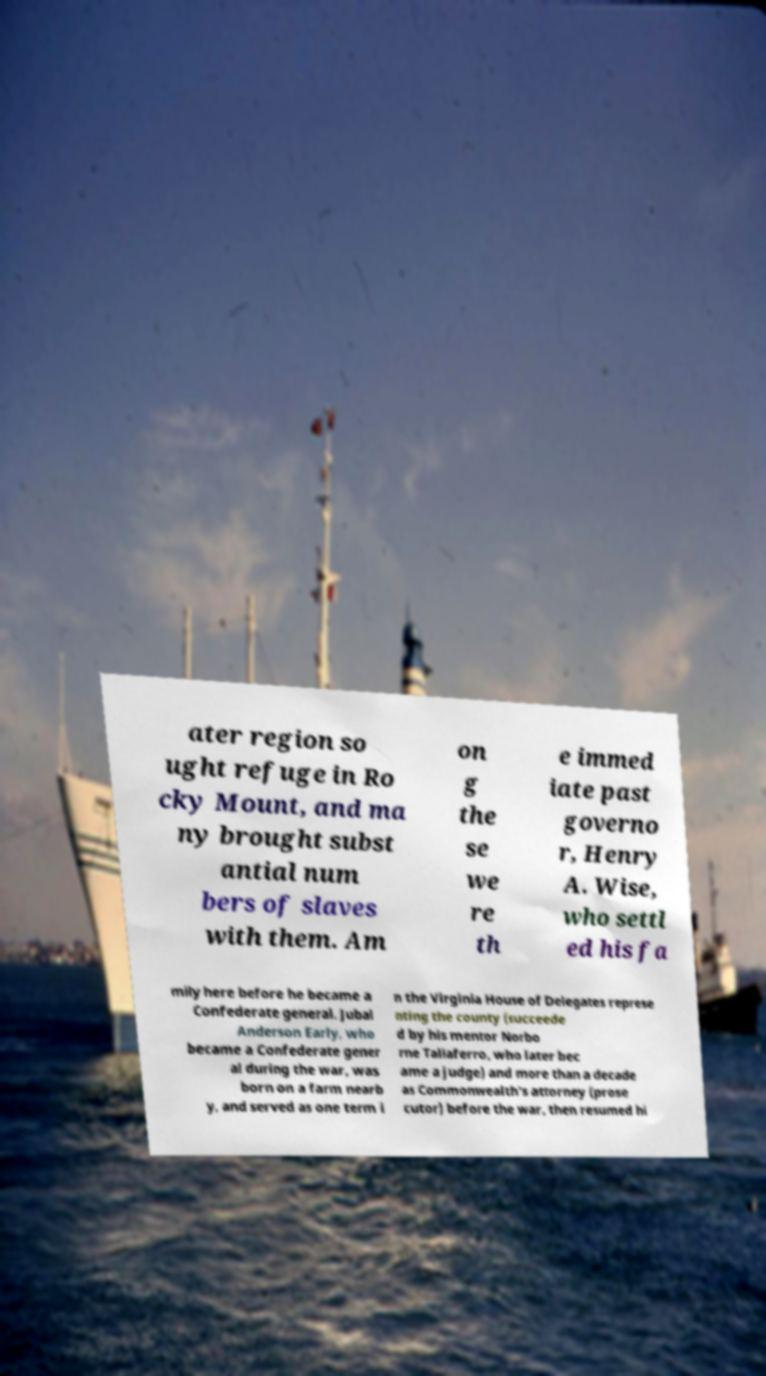I need the written content from this picture converted into text. Can you do that? ater region so ught refuge in Ro cky Mount, and ma ny brought subst antial num bers of slaves with them. Am on g the se we re th e immed iate past governo r, Henry A. Wise, who settl ed his fa mily here before he became a Confederate general. Jubal Anderson Early, who became a Confederate gener al during the war, was born on a farm nearb y, and served as one term i n the Virginia House of Delegates represe nting the county (succeede d by his mentor Norbo rne Taliaferro, who later bec ame a judge) and more than a decade as Commonwealth's attorney (prose cutor) before the war, then resumed hi 